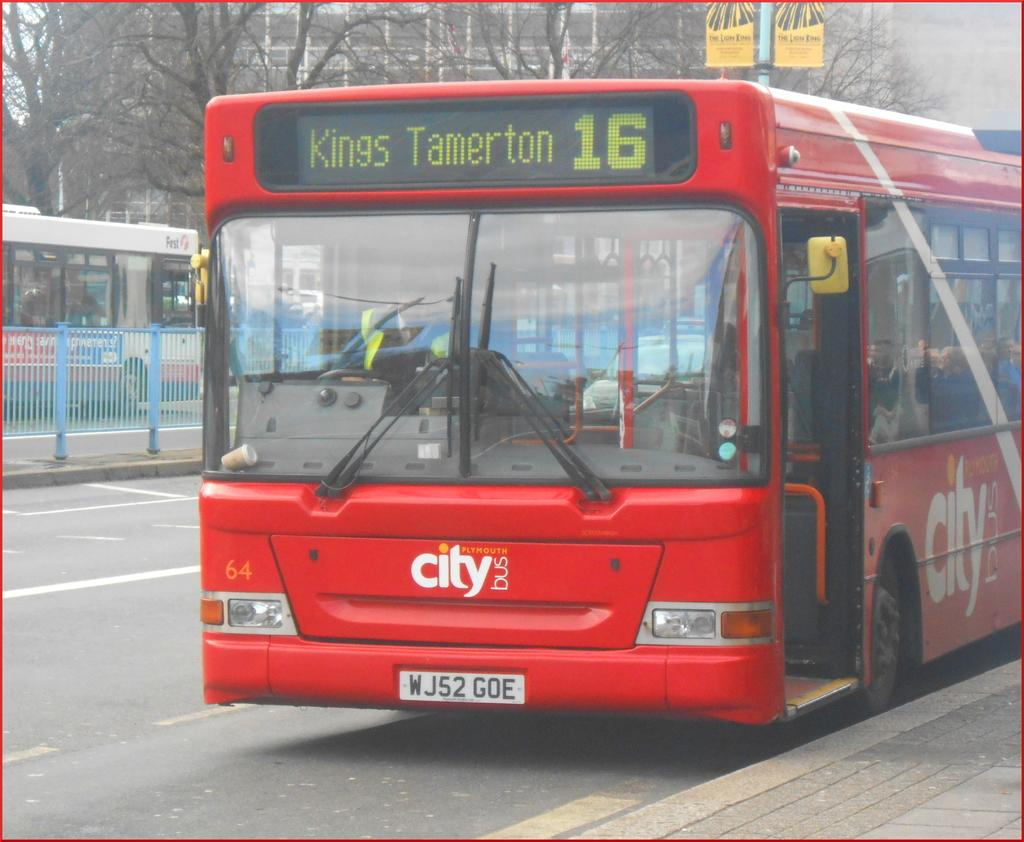<image>
Offer a succinct explanation of the picture presented. A red city bus that is heading to Tamerton. 